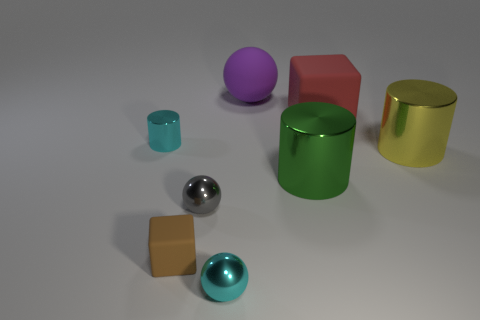There is a large green metal thing; what shape is it?
Provide a short and direct response. Cylinder. What number of things are large rubber objects or blue metal cylinders?
Keep it short and to the point. 2. Does the cylinder to the left of the large green thing have the same color as the tiny sphere in front of the small brown rubber cube?
Your answer should be compact. Yes. What number of other things are there of the same shape as the tiny gray object?
Your response must be concise. 2. Is there a tiny brown rubber object?
Keep it short and to the point. Yes. What number of objects are either tiny gray balls or metal objects right of the gray object?
Offer a terse response. 4. Do the block that is to the left of the red object and the small cyan cylinder have the same size?
Keep it short and to the point. Yes. What number of other objects are there of the same size as the gray sphere?
Your response must be concise. 3. What color is the tiny rubber thing?
Keep it short and to the point. Brown. There is a cyan thing that is in front of the cyan cylinder; what is its material?
Ensure brevity in your answer.  Metal. 